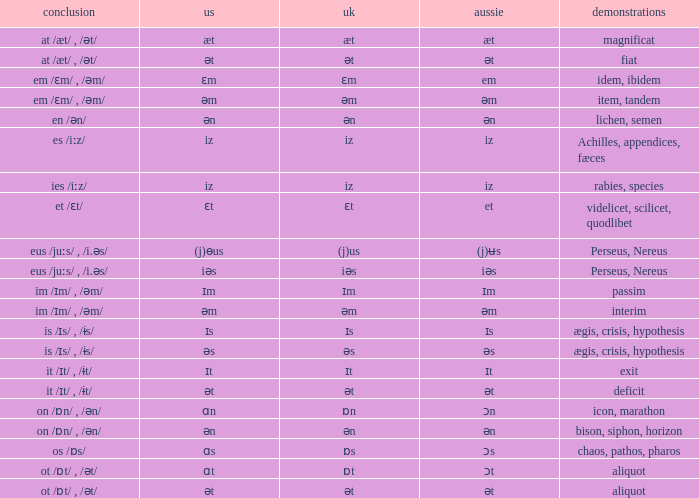Which British has Examples of exit? Ɪt. 